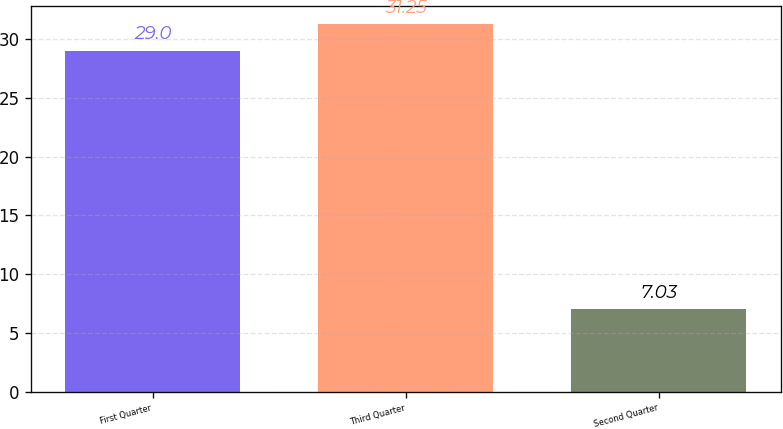<chart> <loc_0><loc_0><loc_500><loc_500><bar_chart><fcel>First Quarter<fcel>Third Quarter<fcel>Second Quarter<nl><fcel>29<fcel>31.25<fcel>7.03<nl></chart> 